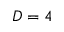<formula> <loc_0><loc_0><loc_500><loc_500>D = 4</formula> 